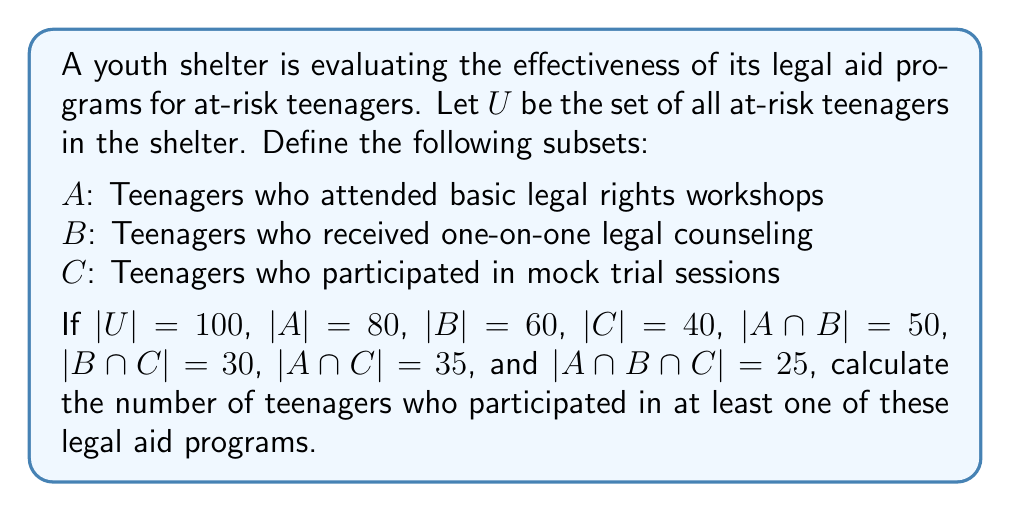Give your solution to this math problem. To solve this problem, we'll use the Inclusion-Exclusion Principle for three sets:

$$|A \cup B \cup C| = |A| + |B| + |C| - |A \cap B| - |A \cap C| - |B \cap C| + |A \cap B \cap C|$$

Let's substitute the given values:

$$|A \cup B \cup C| = 80 + 60 + 40 - 50 - 35 - 30 + 25$$

Now, let's calculate step by step:

1) First, add the individual set sizes:
   $80 + 60 + 40 = 180$

2) Subtract the pairwise intersections:
   $180 - 50 - 35 - 30 = 65$

3) Add back the triple intersection:
   $65 + 25 = 90$

Therefore, the number of teenagers who participated in at least one of these legal aid programs is 90.

We can verify that this makes sense, as it's less than the total number of teenagers in the shelter (100) but more than any individual program's participation (80, 60, or 40).
Answer: 90 teenagers 